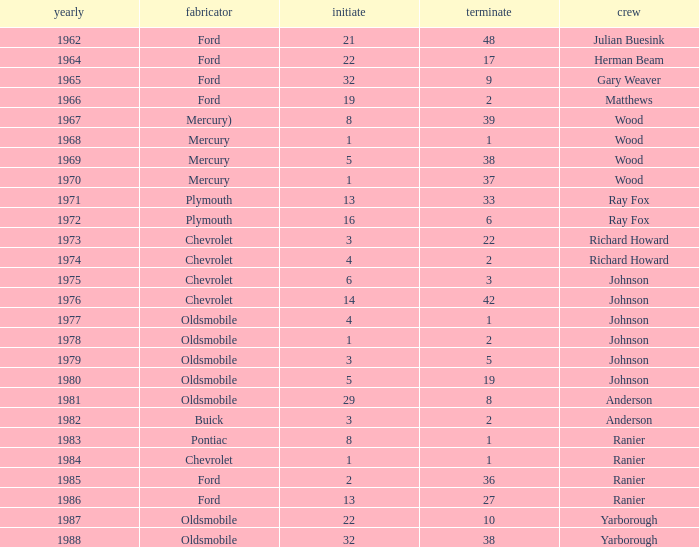What is the smallest finish time for a race where start was less than 3, buick was the manufacturer, and the race was held after 1978? None. 